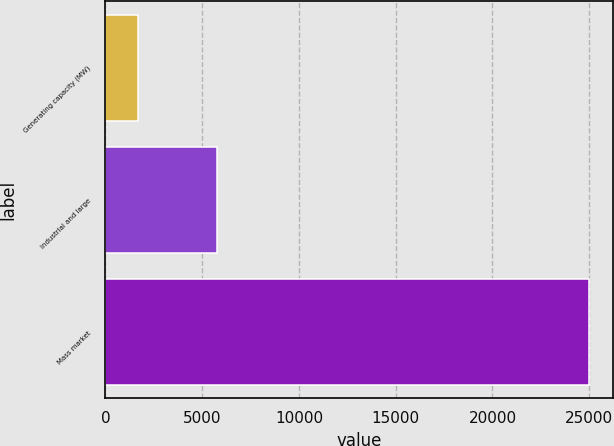<chart> <loc_0><loc_0><loc_500><loc_500><bar_chart><fcel>Generating capacity (MW)<fcel>Industrial and large<fcel>Mass market<nl><fcel>1668<fcel>5775<fcel>24989<nl></chart> 